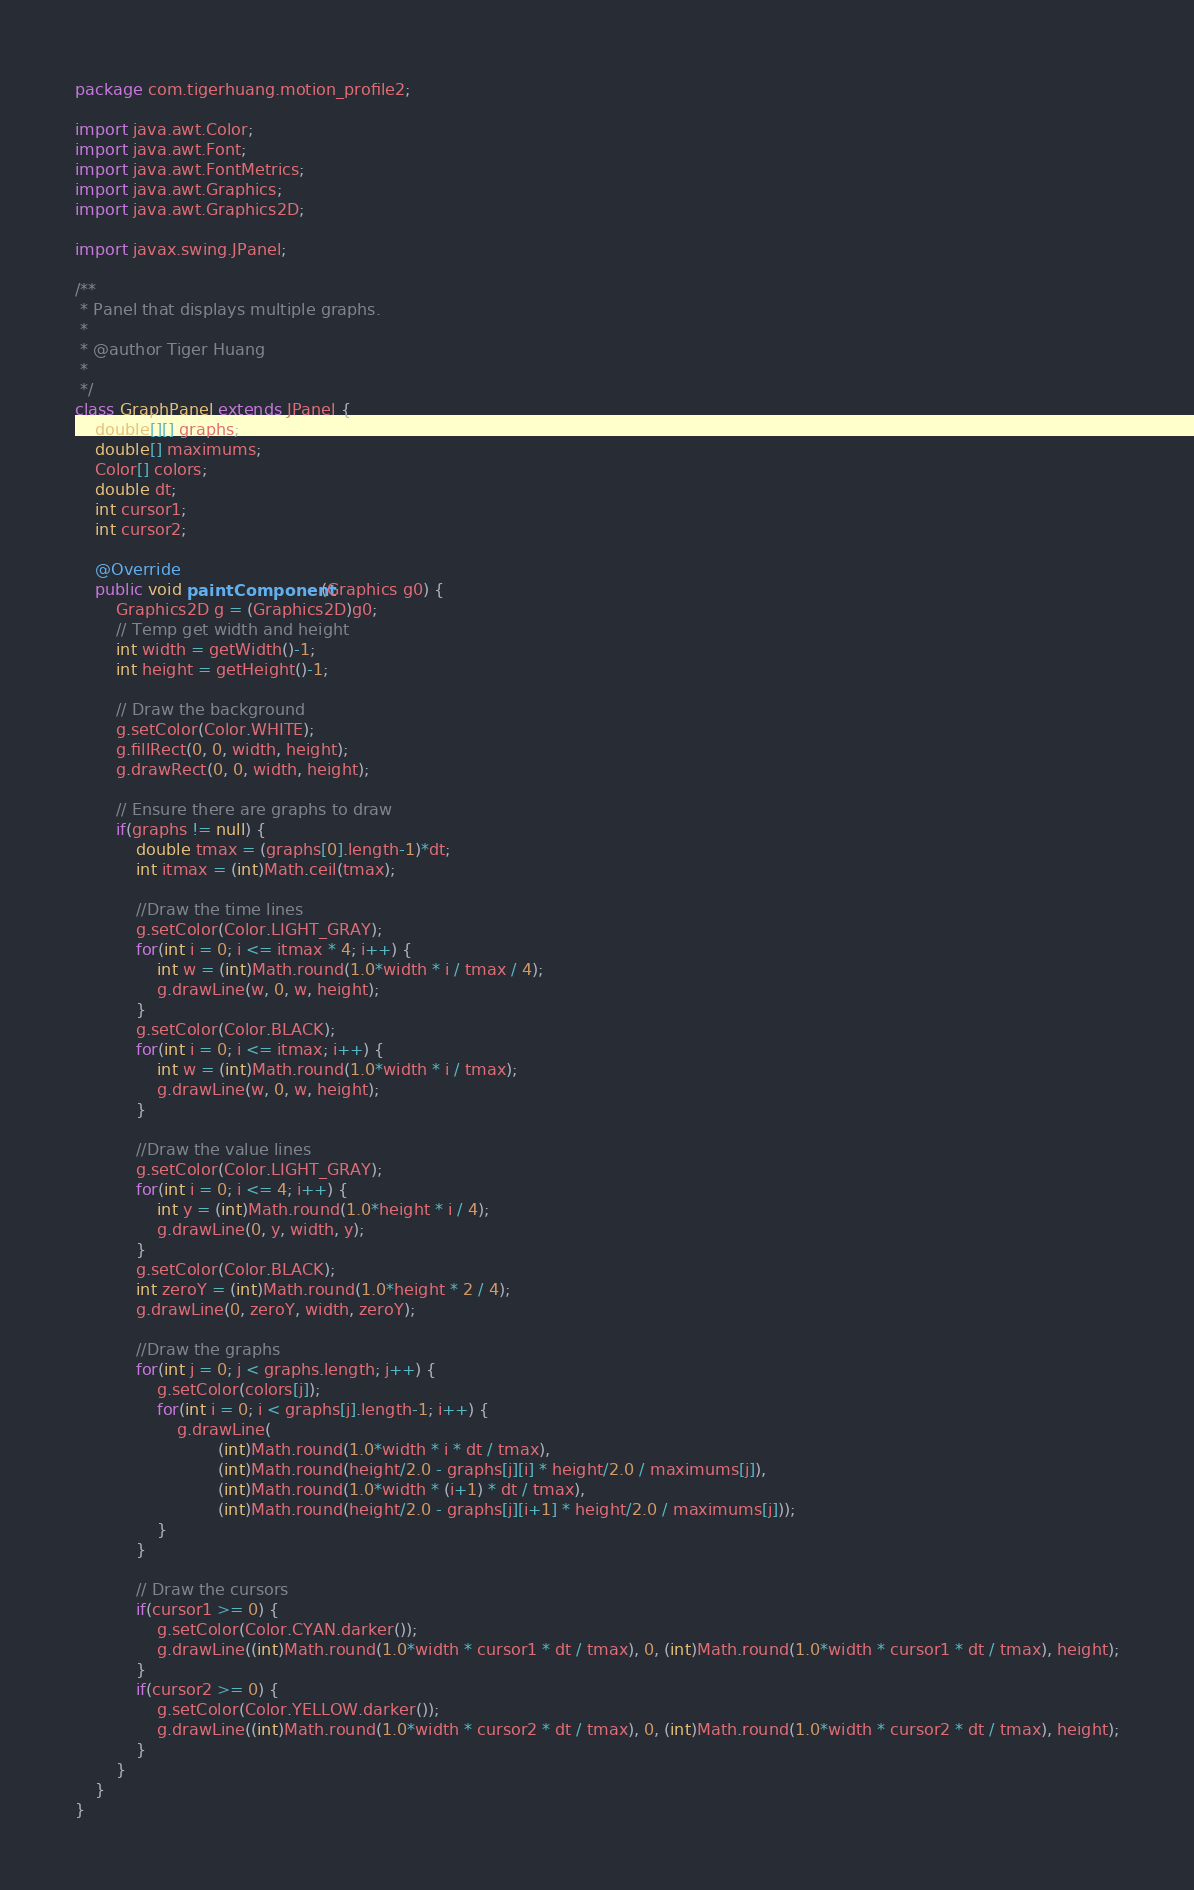<code> <loc_0><loc_0><loc_500><loc_500><_Java_>package com.tigerhuang.motion_profile2;

import java.awt.Color;
import java.awt.Font;
import java.awt.FontMetrics;
import java.awt.Graphics;
import java.awt.Graphics2D;

import javax.swing.JPanel;

/**
 * Panel that displays multiple graphs.
 * 
 * @author Tiger Huang
 *
 */
class GraphPanel extends JPanel {
	double[][] graphs;
	double[] maximums;
	Color[] colors;
	double dt;
	int cursor1;
	int cursor2;

	@Override
	public void paintComponent(Graphics g0) {
		Graphics2D g = (Graphics2D)g0;
		// Temp get width and height
		int width = getWidth()-1;
		int height = getHeight()-1;

		// Draw the background
		g.setColor(Color.WHITE);
		g.fillRect(0, 0, width, height);
		g.drawRect(0, 0, width, height);
		
		// Ensure there are graphs to draw
		if(graphs != null) {
			double tmax = (graphs[0].length-1)*dt;
			int itmax = (int)Math.ceil(tmax);
			
			//Draw the time lines
			g.setColor(Color.LIGHT_GRAY);
			for(int i = 0; i <= itmax * 4; i++) {
				int w = (int)Math.round(1.0*width * i / tmax / 4);
				g.drawLine(w, 0, w, height);
			}
			g.setColor(Color.BLACK);
			for(int i = 0; i <= itmax; i++) {
				int w = (int)Math.round(1.0*width * i / tmax);
				g.drawLine(w, 0, w, height);
			}
			
			//Draw the value lines
			g.setColor(Color.LIGHT_GRAY);
			for(int i = 0; i <= 4; i++) {
				int y = (int)Math.round(1.0*height * i / 4);
				g.drawLine(0, y, width, y);
			}
			g.setColor(Color.BLACK);
			int zeroY = (int)Math.round(1.0*height * 2 / 4);
			g.drawLine(0, zeroY, width, zeroY);
			
			//Draw the graphs
			for(int j = 0; j < graphs.length; j++) {
				g.setColor(colors[j]);
				for(int i = 0; i < graphs[j].length-1; i++) {
					g.drawLine(
							(int)Math.round(1.0*width * i * dt / tmax),
							(int)Math.round(height/2.0 - graphs[j][i] * height/2.0 / maximums[j]),
							(int)Math.round(1.0*width * (i+1) * dt / tmax),
							(int)Math.round(height/2.0 - graphs[j][i+1] * height/2.0 / maximums[j]));
				}
			}

			// Draw the cursors
			if(cursor1 >= 0) {
				g.setColor(Color.CYAN.darker());
				g.drawLine((int)Math.round(1.0*width * cursor1 * dt / tmax), 0, (int)Math.round(1.0*width * cursor1 * dt / tmax), height);
			}
			if(cursor2 >= 0) {
				g.setColor(Color.YELLOW.darker());
				g.drawLine((int)Math.round(1.0*width * cursor2 * dt / tmax), 0, (int)Math.round(1.0*width * cursor2 * dt / tmax), height);
			}
		}
	}
}
</code> 